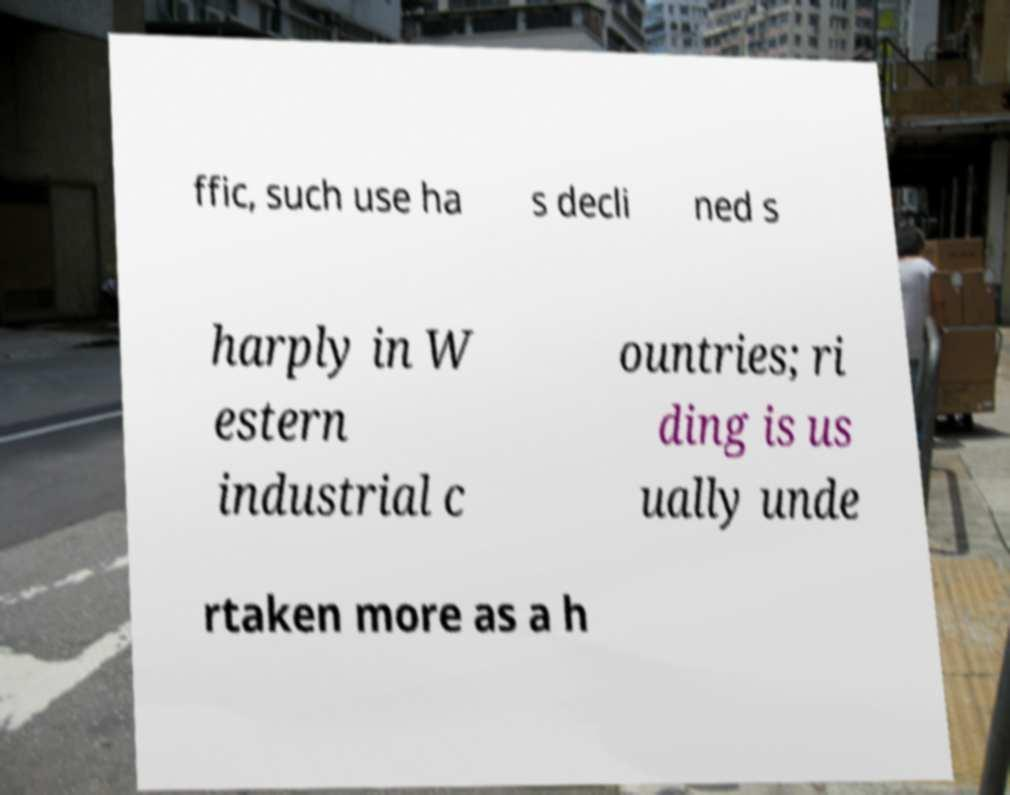Please identify and transcribe the text found in this image. ffic, such use ha s decli ned s harply in W estern industrial c ountries; ri ding is us ually unde rtaken more as a h 